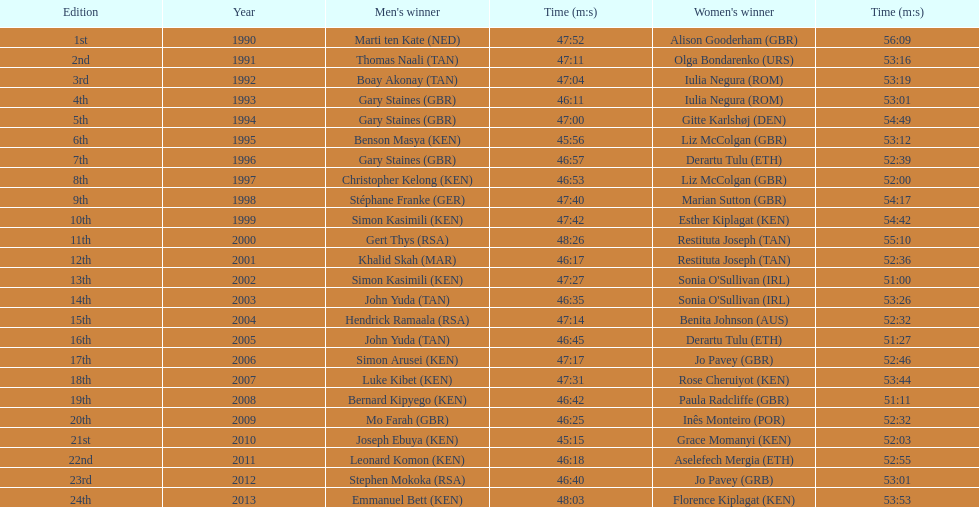What place did sonia o'sullivan finish in 2003? 14th. How long did it take her to finish? 53:26. 